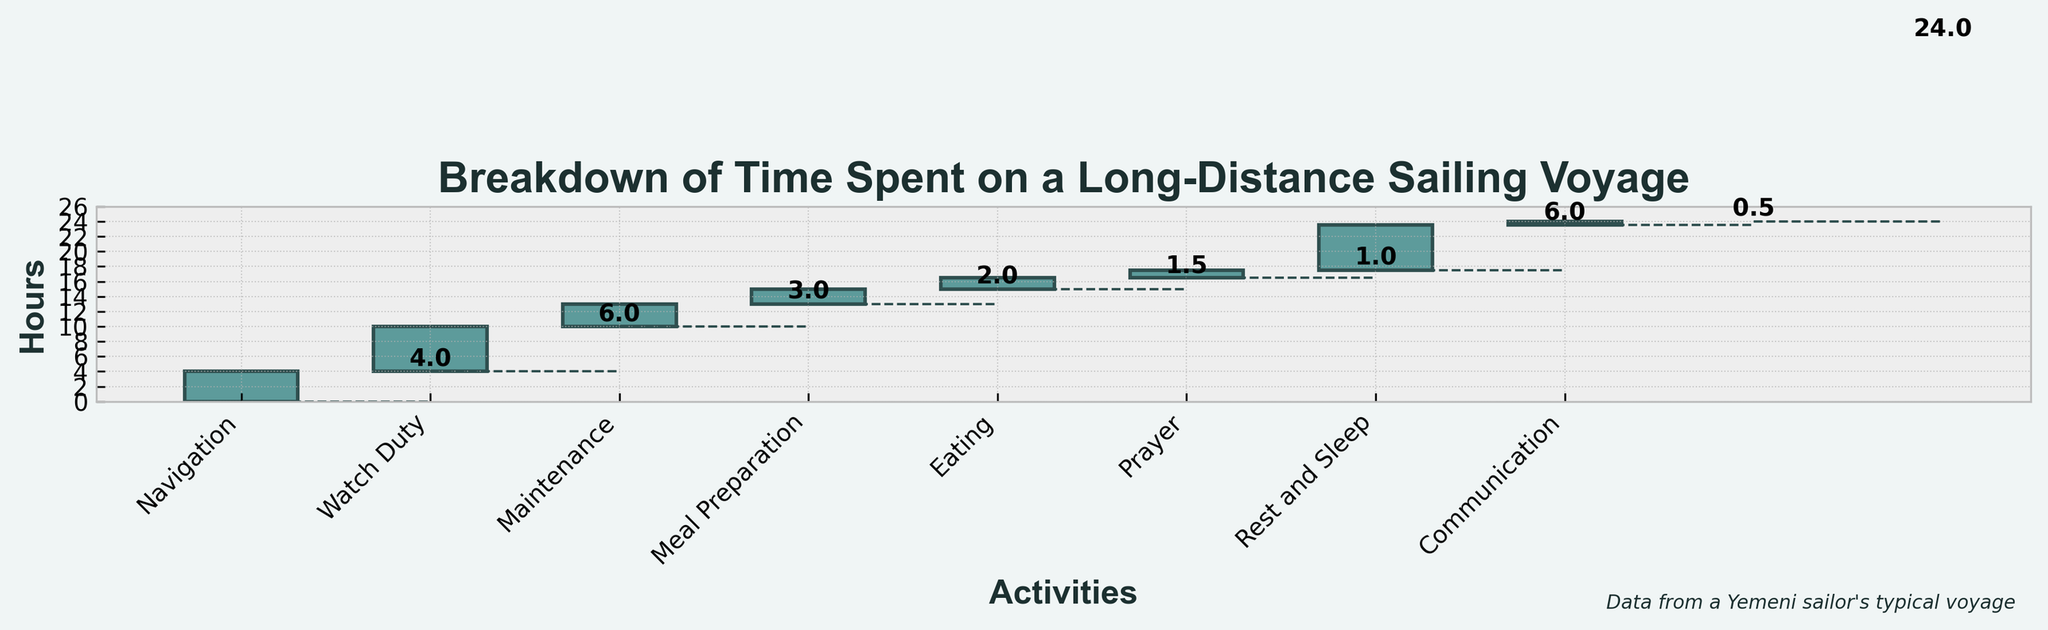What's the title of the chart? The title of the chart is the text displayed at the top of the figure, giving a summary of the data presented. It means the main focus or context of the chart.
Answer: Breakdown of Time Spent on a Long-Distance Sailing Voyage How many hours are spent on navigation during the voyage? Navigation time is represented by a single bar labeled "Navigation." The height or length of this bar corresponds to the time spent on navigation as per the chart.
Answer: 4 What is the color of the bars representing the activities? The bars are the rectangular shapes that denote each category/activity. The entire bar area for these categories share a specific color which can be described.
Answer: Teal color How many hours in total are dedicated to eating and meal preparation combined? To find the combined hours for eating and meal preparation, add the hours spent on each activity, which are represented by two separate bars labeled "Eating" and "Meal Preparation." The chart indicates 2 hours for Meal Preparation and 1.5 hours for Eating.
Answer: 3.5 By how many hours does Rest and Sleep exceed Maintenance? The hours for each category are given by the length of the bars. To find the difference, subtract the hours for Maintenance (3) from the hours for Rest and Sleep (6).
Answer: 3 Which activity takes the most time? The highest bar in the chart represents the activity with the most time spent. Observing the chart, "Rest and Sleep" has the highest value.
Answer: Rest and Sleep How many activities take less than 2 hours? Review each activity’s bar and count those with a value (height) less than 2 hours. The categories are Eating (1.5) and Communication (0.5).
Answer: 2 Is more time spent on maintenance or meal preparation? Compare the heights/values of the bars labeled "Maintenance" and "Meal Preparation." Maintenance has a value of 3, whereas Meal Preparation has a value of 2.
Answer: Maintenance What's the range of hours spent on different activities? The range is calculated by subtracting the minimum number of hours spent on any activity from the maximum number of hours. Here, the maximum is "Rest and Sleep" (6) and the minimum (excluding 0) is Communication (0.5).
Answer: 5.5 Does the chart show any break periods throughout the voyage? Break periods can be inferred where the bars are comparatively higher for rest-related activities or the presence of labels indicating such activities. Here, "Rest and Sleep" indicates break periods.
Answer: Yes 